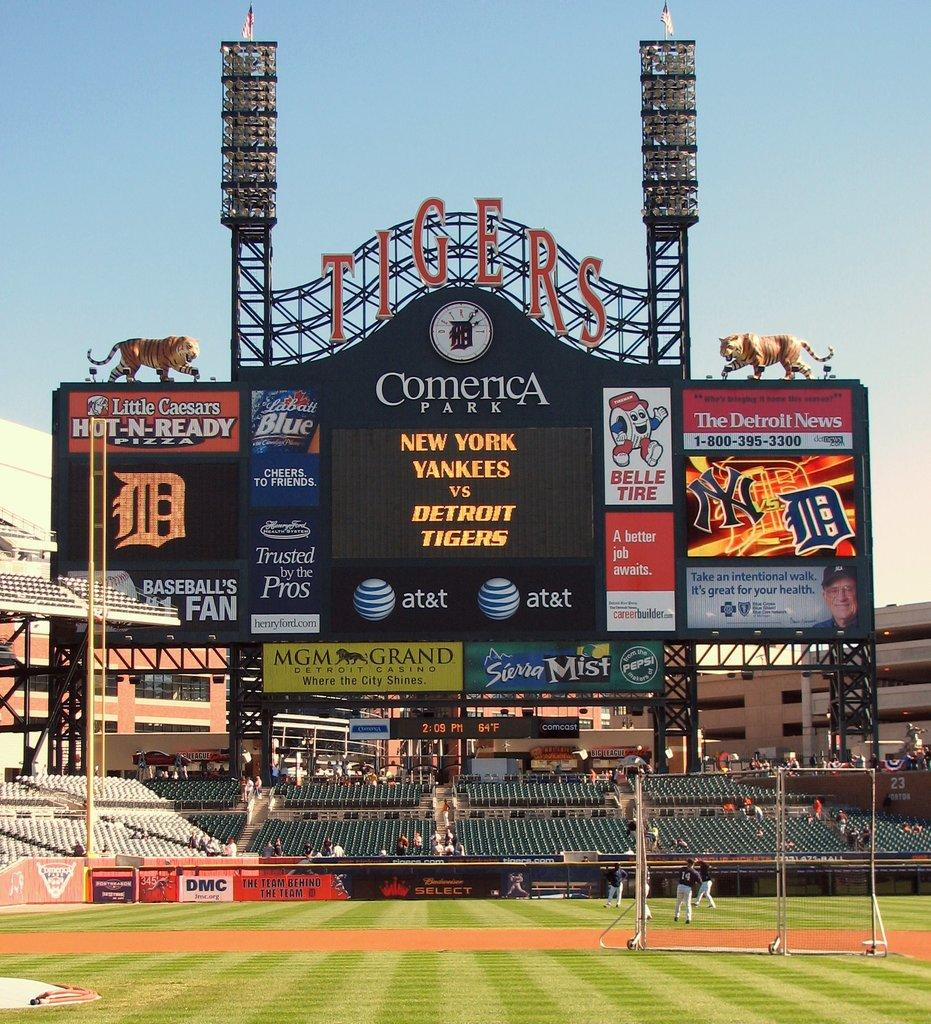<image>
Render a clear and concise summary of the photo. A huge scoreboard for the Tigers sponsored by the MGM Grand. 